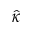Convert formula to latex. <formula><loc_0><loc_0><loc_500><loc_500>\hat { \kappa }</formula> 